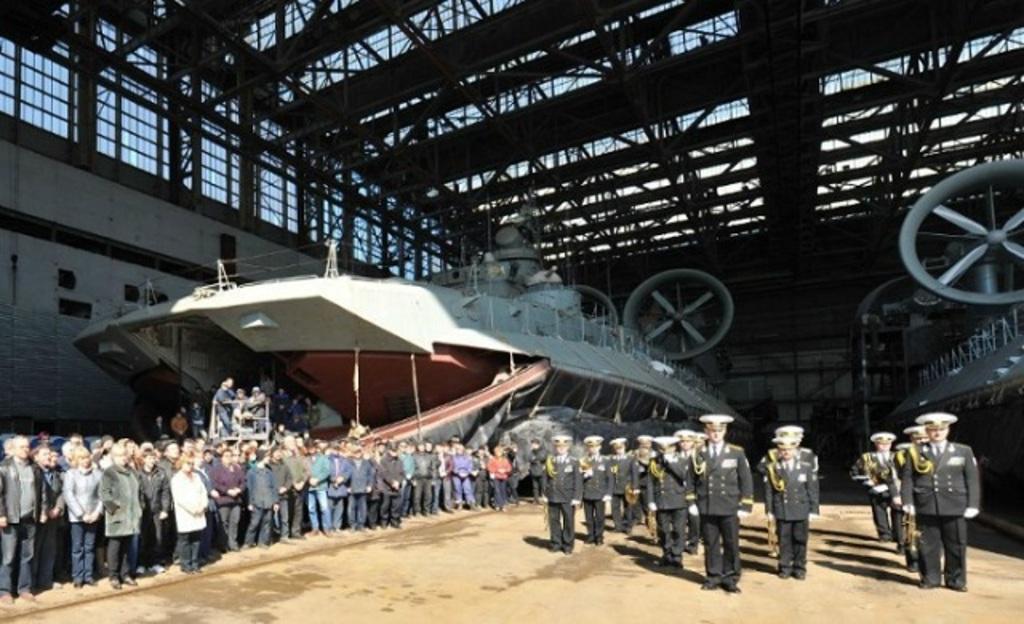Can you describe this image briefly? In this image there are a few officers standing, behind them there are two ships, beside them there are a few people standing and watching, in the background of the image there is a wall, on top of the image there is a rooftop with metal rods. 